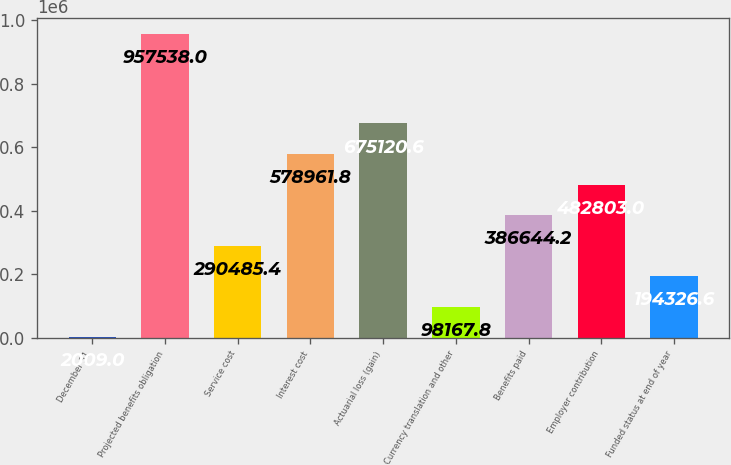Convert chart. <chart><loc_0><loc_0><loc_500><loc_500><bar_chart><fcel>December 31<fcel>Projected benefits obligation<fcel>Service cost<fcel>Interest cost<fcel>Actuarial loss (gain)<fcel>Currency translation and other<fcel>Benefits paid<fcel>Employer contribution<fcel>Funded status at end of year<nl><fcel>2009<fcel>957538<fcel>290485<fcel>578962<fcel>675121<fcel>98167.8<fcel>386644<fcel>482803<fcel>194327<nl></chart> 